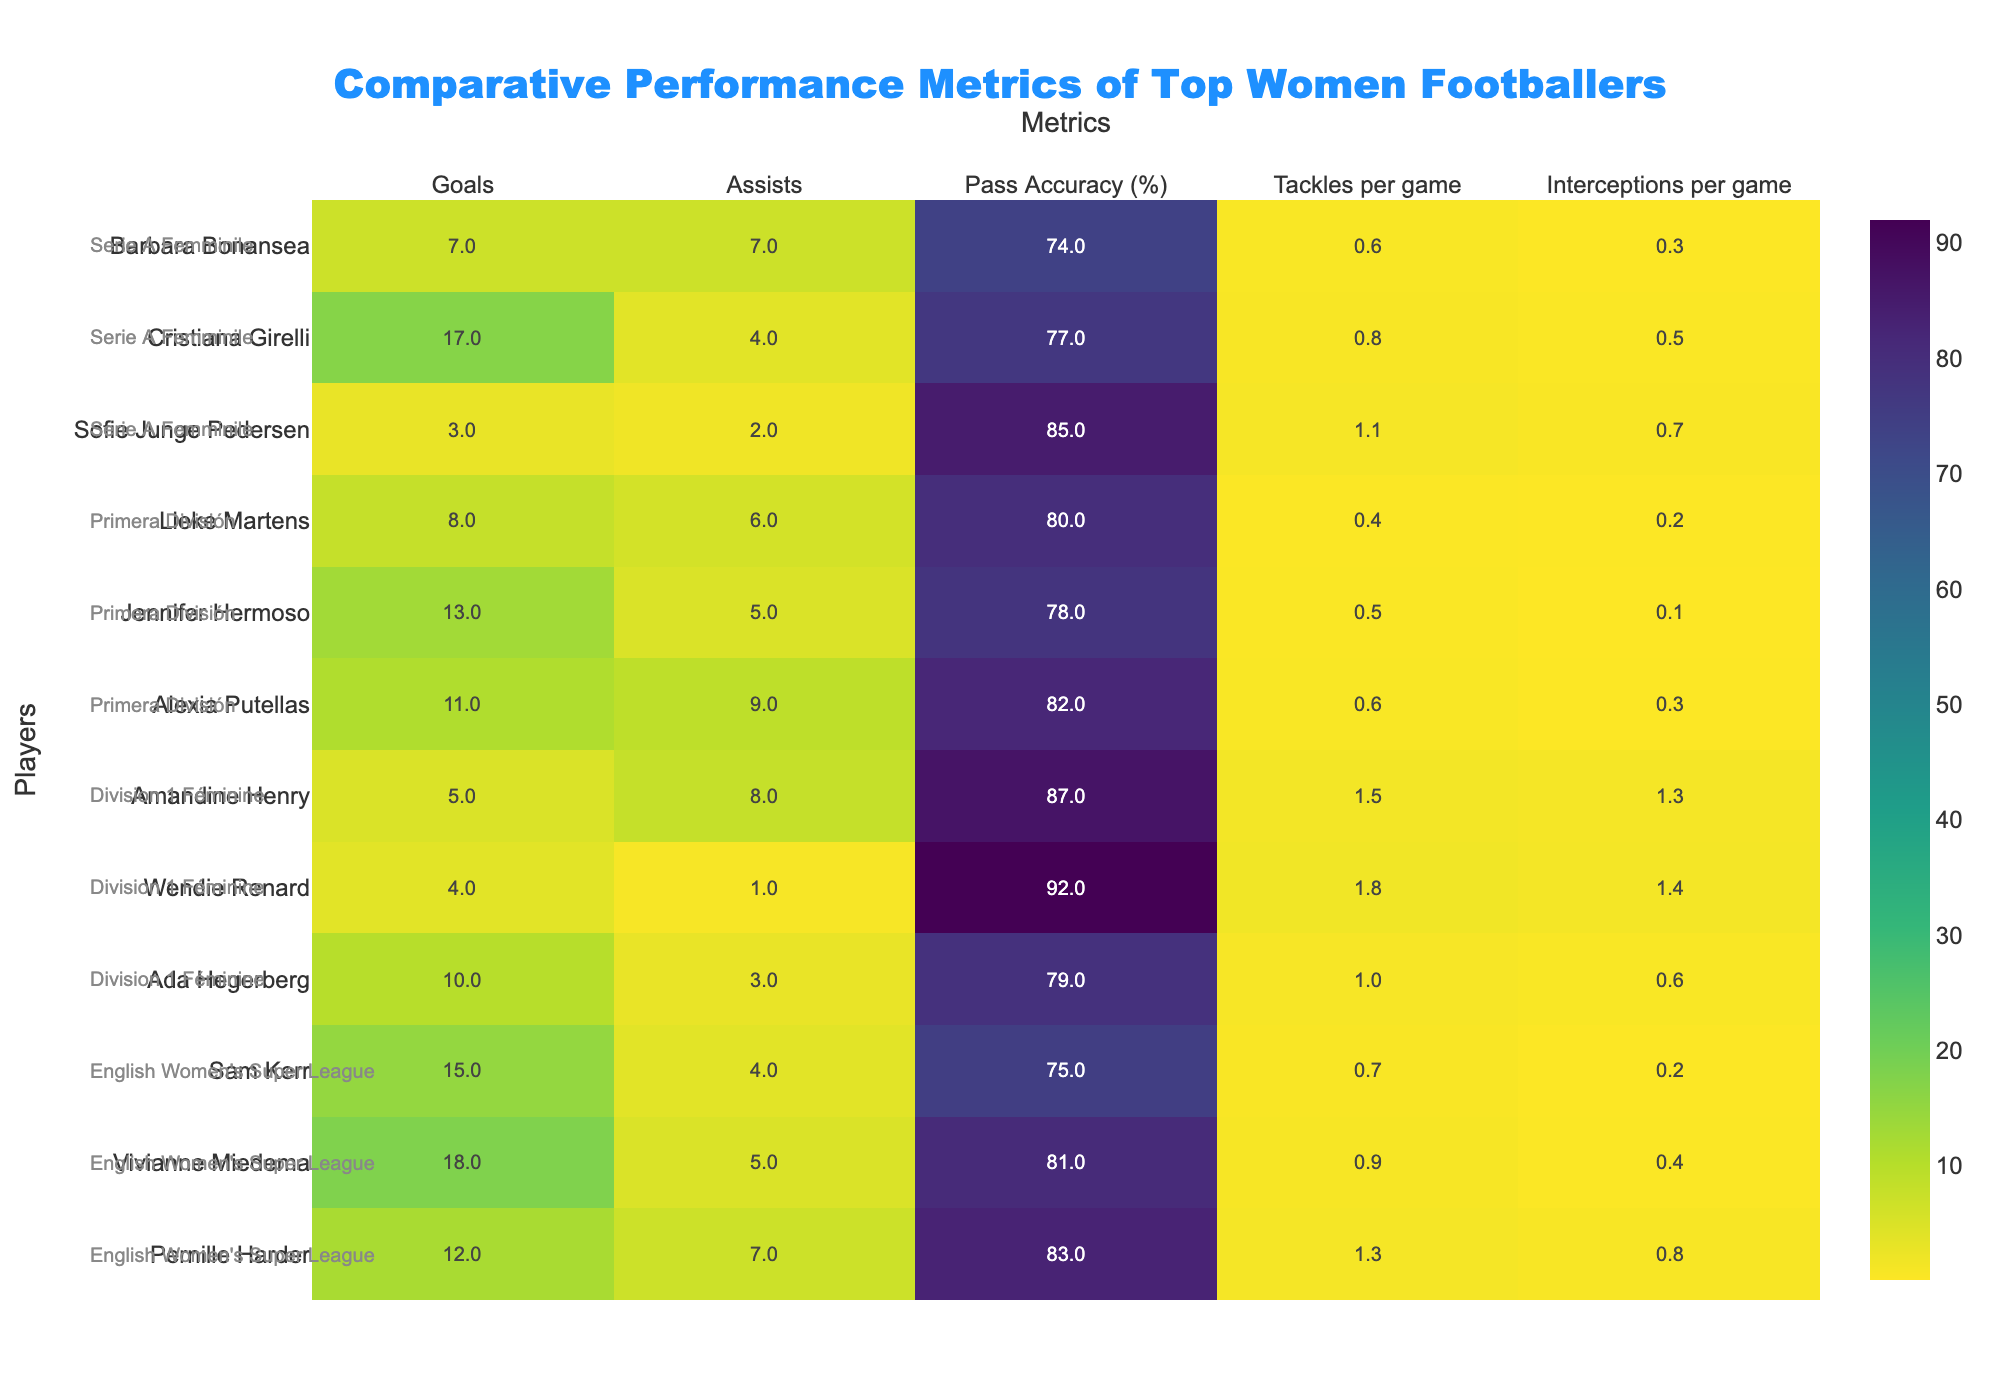What is the title of the heatmap? Look at the top of the heatmap where the title is usually placed. The title is often displayed prominently to describe what the heatmap represents.
Answer: Comparative Performance Metrics of Top Women Footballers Which player has the highest number of goals? Find the column labeled "Goals" and look for the highest value. Check the corresponding player name.
Answer: Vivianne Miedema Which player has the lowest pass accuracy? Identify the column "Pass Accuracy (%)" and locate the lowest percentage. Check the corresponding player name in that row.
Answer: Barbara Bonansea How many players have more than 10 goals? Go through the "Goals" column and count the number of players who have values greater than 10.
Answer: 5 Which league has the highest occurrence on the heatmap? Look at the annotations added for each player to find their respective leagues. Count the occurrences of each league and determine which one appears the most.
Answer: English Women's Super League What is the sum of assists for players in Division 1 Féminine? Locate the players in "Division 1 Féminine" and add their "Assists" numbers: Wendie Renard (1), Amandine Henry (8), Ada Hegerberg (3).
Answer: 12 Which player from Serie A Femminile has the highest tackles per game? Find the players from "Serie A Femminile" and compare their values in the "Tackles per game" column.
Answer: Sofie Junge Pedersen Who has a higher pass accuracy: Sam Kerr or Jennifer Hermoso? Compare the values in the "Pass Accuracy (%)" column for Sam Kerr and Jennifer Hermoso.
Answer: Sam Kerr Which player has the highest number of interceptions per game? Look at the "Interceptions per game" column and find the highest value. Check the corresponding player name.
Answer: Wendie Renard Between Pernille Harder and Alexia Putellas, who has more assists? Compare the values in the "Assists" column for Pernille Harder and Alexia Putellas.
Answer: Alexia Putellas 